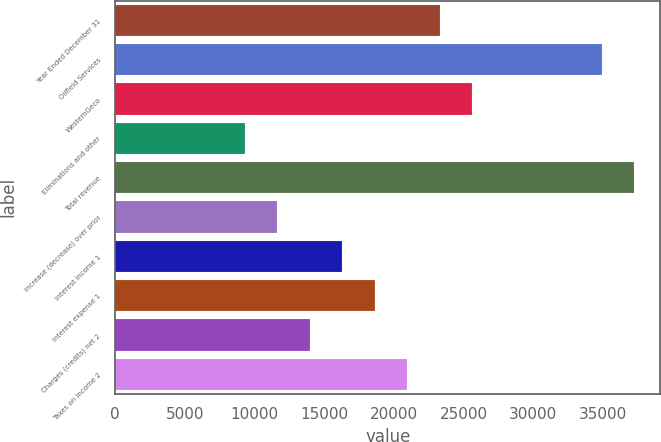Convert chart to OTSL. <chart><loc_0><loc_0><loc_500><loc_500><bar_chart><fcel>Year Ended December 31<fcel>Oilfield Services<fcel>WesternGeco<fcel>Eliminations and other<fcel>Total revenue<fcel>increase (decrease) over prior<fcel>Interest income 1<fcel>Interest expense 1<fcel>Charges (credits) net 2<fcel>Taxes on income 2<nl><fcel>23277<fcel>34915.2<fcel>25604.6<fcel>9311.22<fcel>37242.8<fcel>11638.9<fcel>16294.1<fcel>18621.7<fcel>13966.5<fcel>20949.4<nl></chart> 